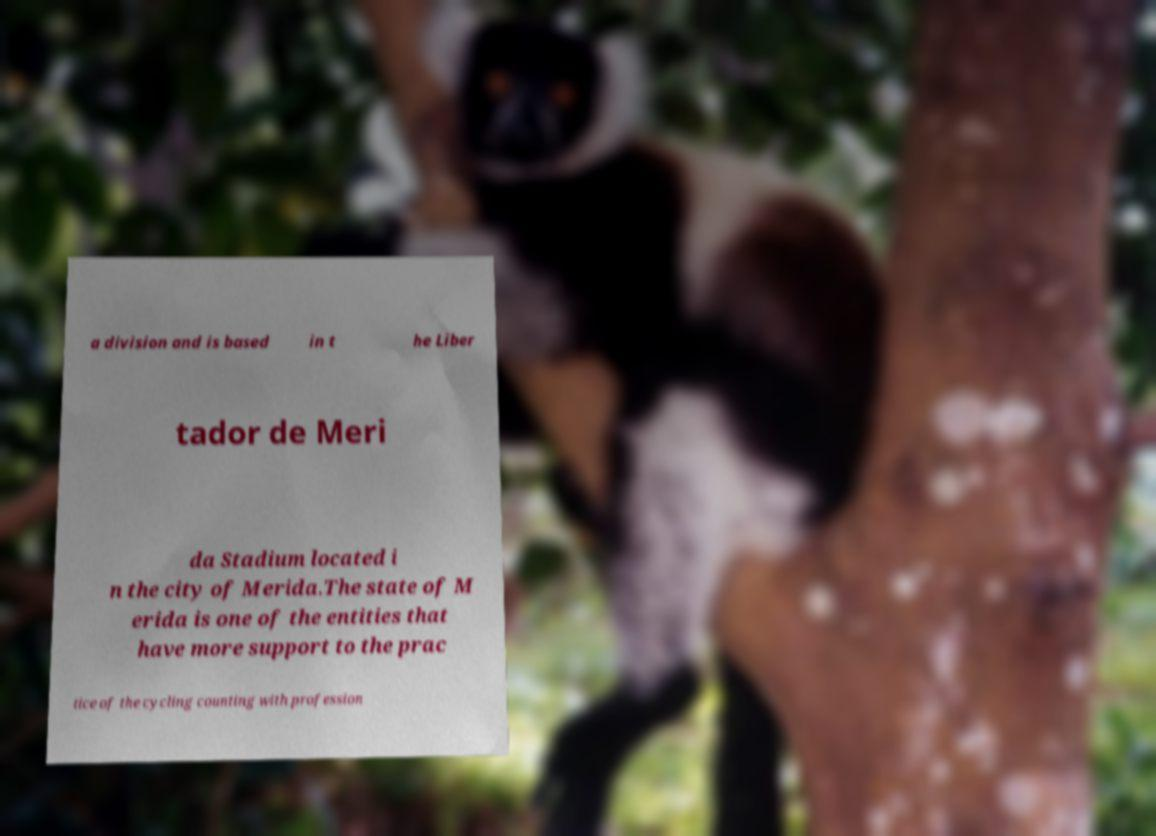Can you accurately transcribe the text from the provided image for me? a division and is based in t he Liber tador de Meri da Stadium located i n the city of Merida.The state of M erida is one of the entities that have more support to the prac tice of the cycling counting with profession 